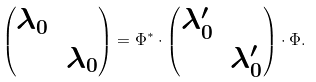Convert formula to latex. <formula><loc_0><loc_0><loc_500><loc_500>\left ( \begin{matrix} \lambda _ { 0 } & \\ & \lambda _ { 0 } \end{matrix} \right ) = \Phi ^ { * } \cdot \left ( \begin{matrix} \lambda _ { 0 } ^ { \prime } & \\ & \lambda _ { 0 } ^ { \prime } \end{matrix} \right ) \cdot \Phi .</formula> 